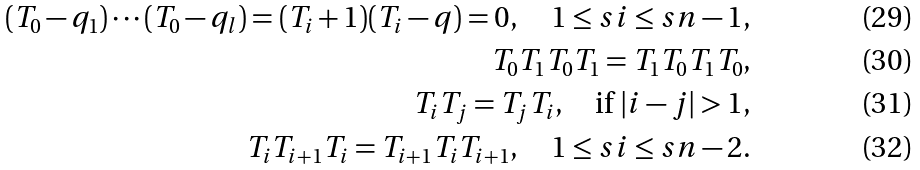<formula> <loc_0><loc_0><loc_500><loc_500>( T _ { 0 } - q _ { 1 } ) \cdots ( T _ { 0 } - q _ { l } ) = ( T _ { i } + 1 ) ( T _ { i } - q ) = 0 , \quad 1 \leq s i \leq s n - 1 , \\ T _ { 0 } T _ { 1 } T _ { 0 } T _ { 1 } = T _ { 1 } T _ { 0 } T _ { 1 } T _ { 0 } , \\ T _ { i } T _ { j } = T _ { j } T _ { i } , \quad \text {if } | i - j | > 1 , \\ T _ { i } T _ { i + 1 } T _ { i } = T _ { i + 1 } T _ { i } T _ { i + 1 } , \quad 1 \leq s i \leq s n - 2 .</formula> 